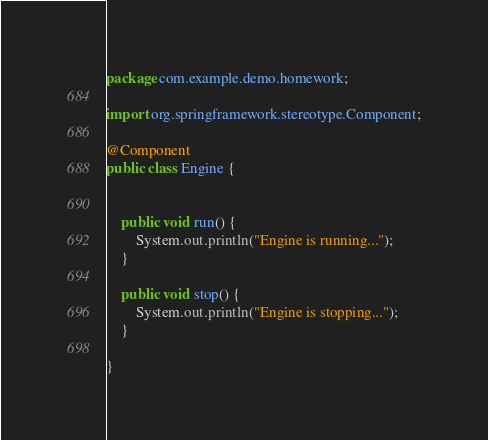<code> <loc_0><loc_0><loc_500><loc_500><_Java_>package com.example.demo.homework;

import org.springframework.stereotype.Component;

@Component
public class Engine {

	
	public void run() {
		System.out.println("Engine is running...");
	}
	
	public void stop() {
		System.out.println("Engine is stopping...");
	}
	
}
</code> 